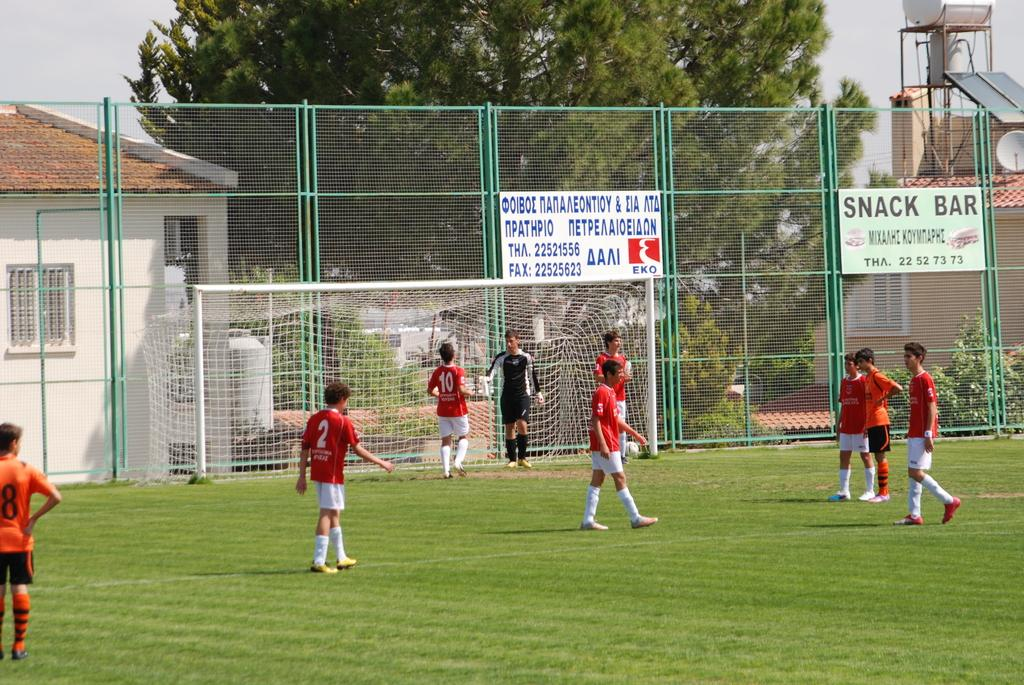<image>
Summarize the visual content of the image. People playing sports on the grass with a sign that says Snack Bar in the back. 